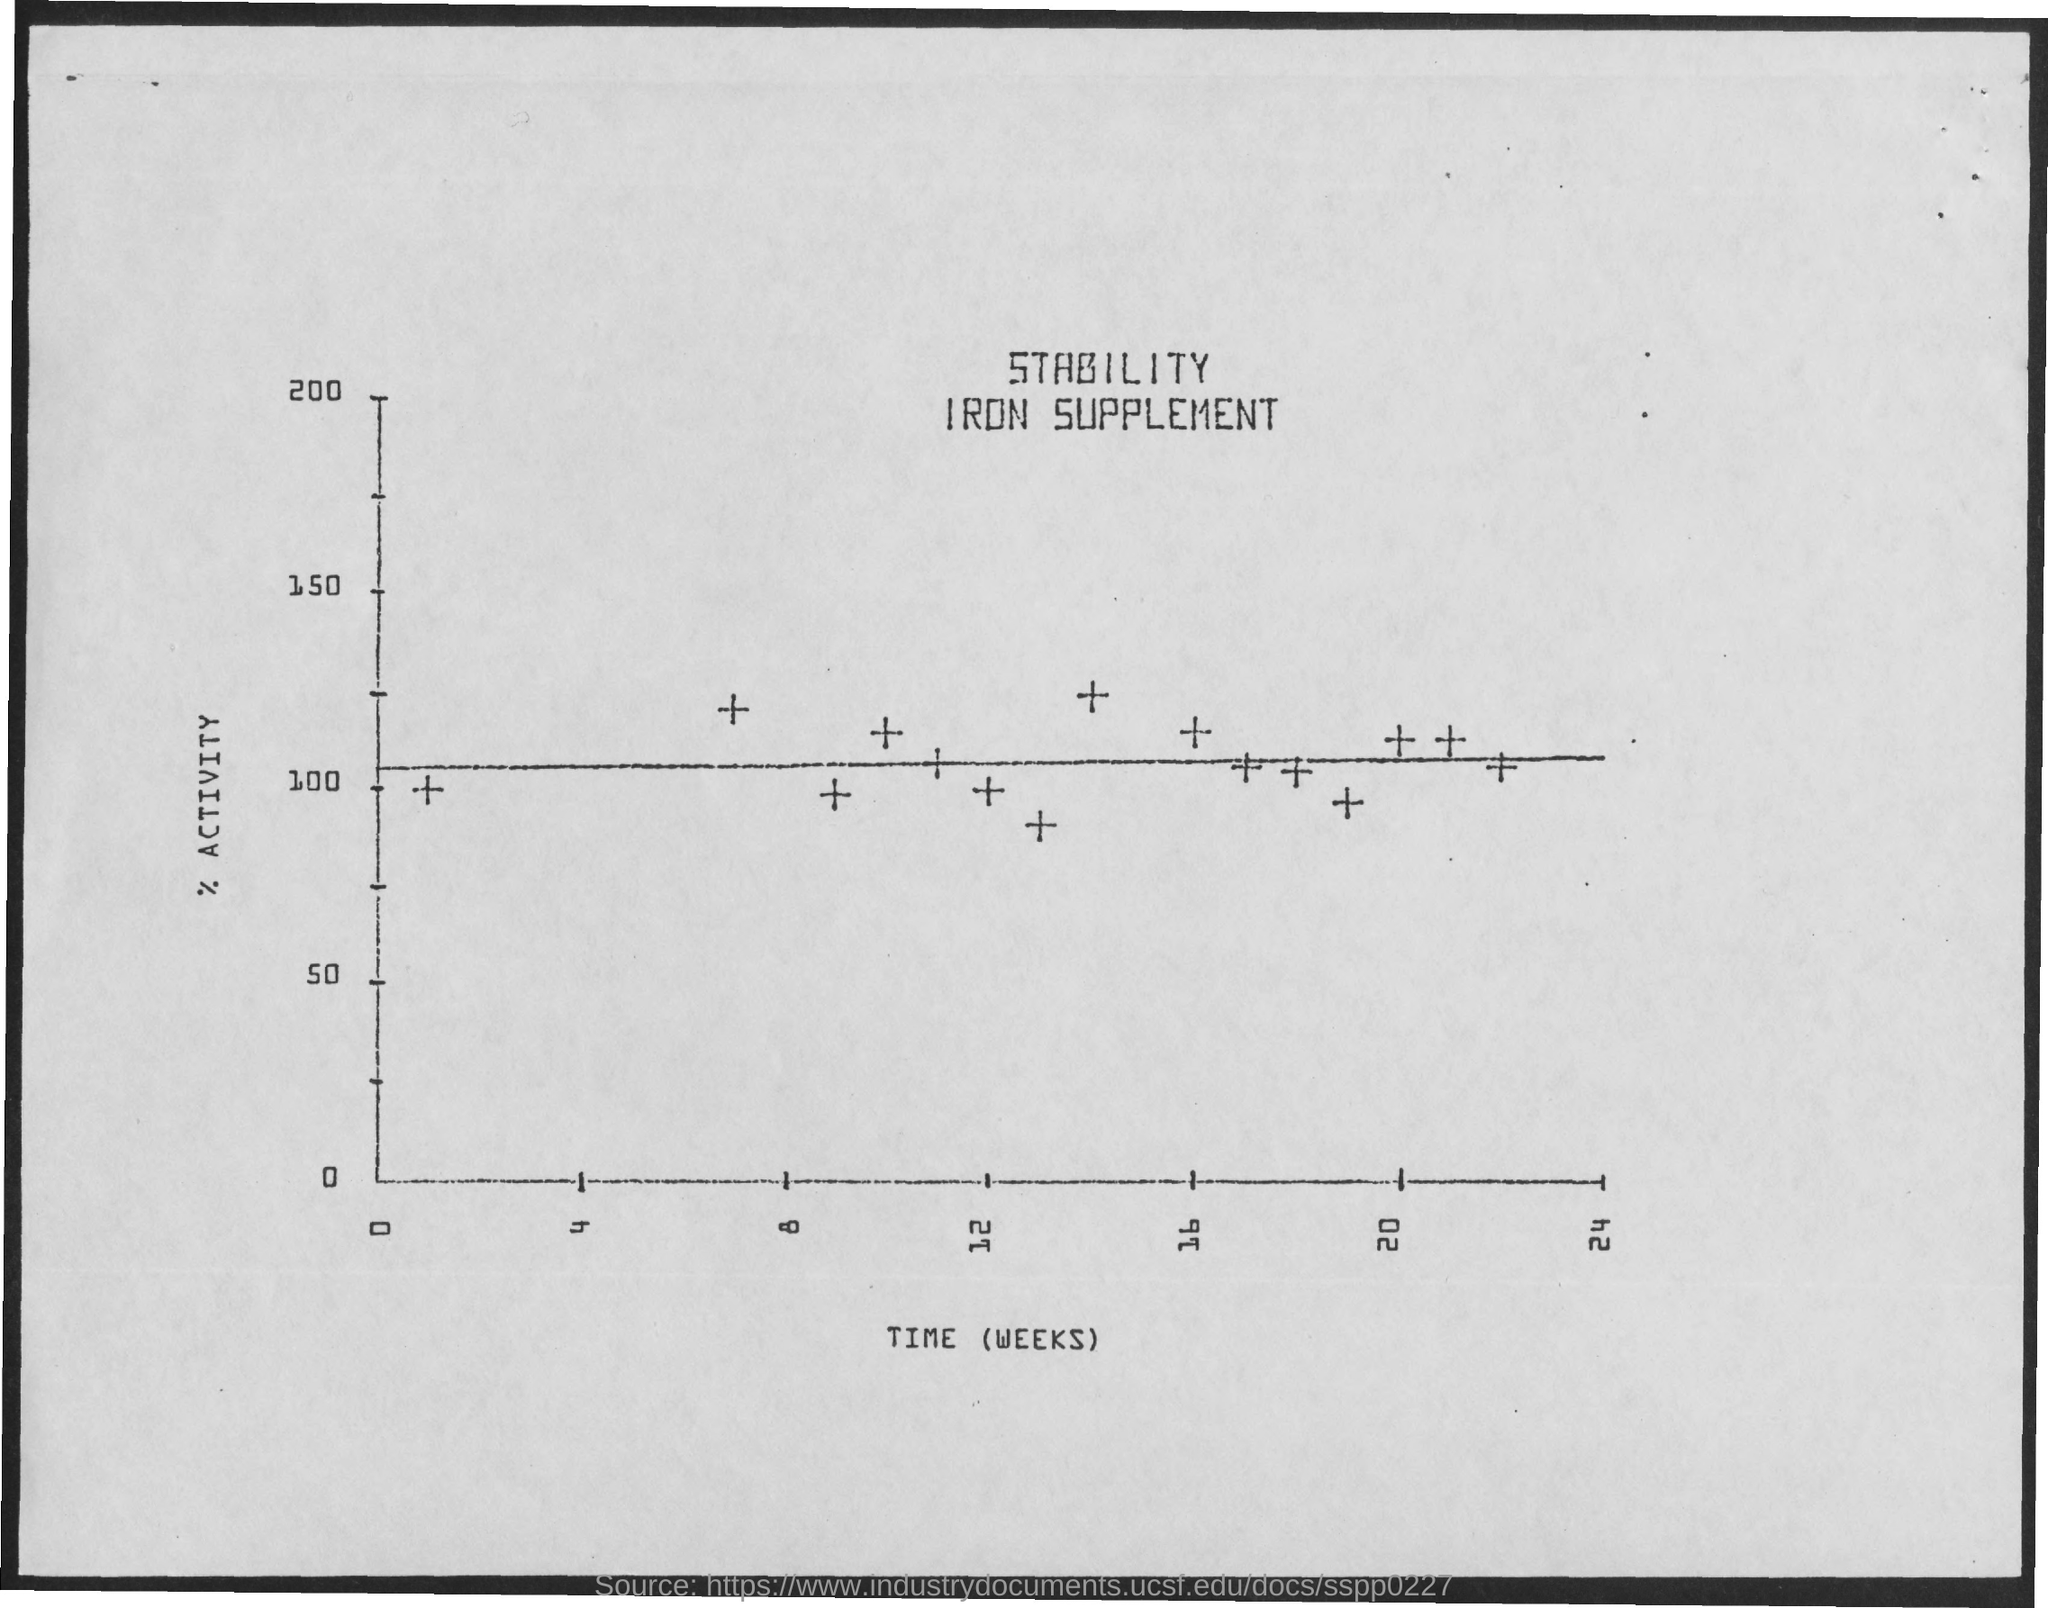What is plotted in the x-axis ?
Your response must be concise. Time (weeks). What is plotted in the y-axis?
Provide a succinct answer. % activity. What is the title of the document?
Make the answer very short. Stability iron supplement. 